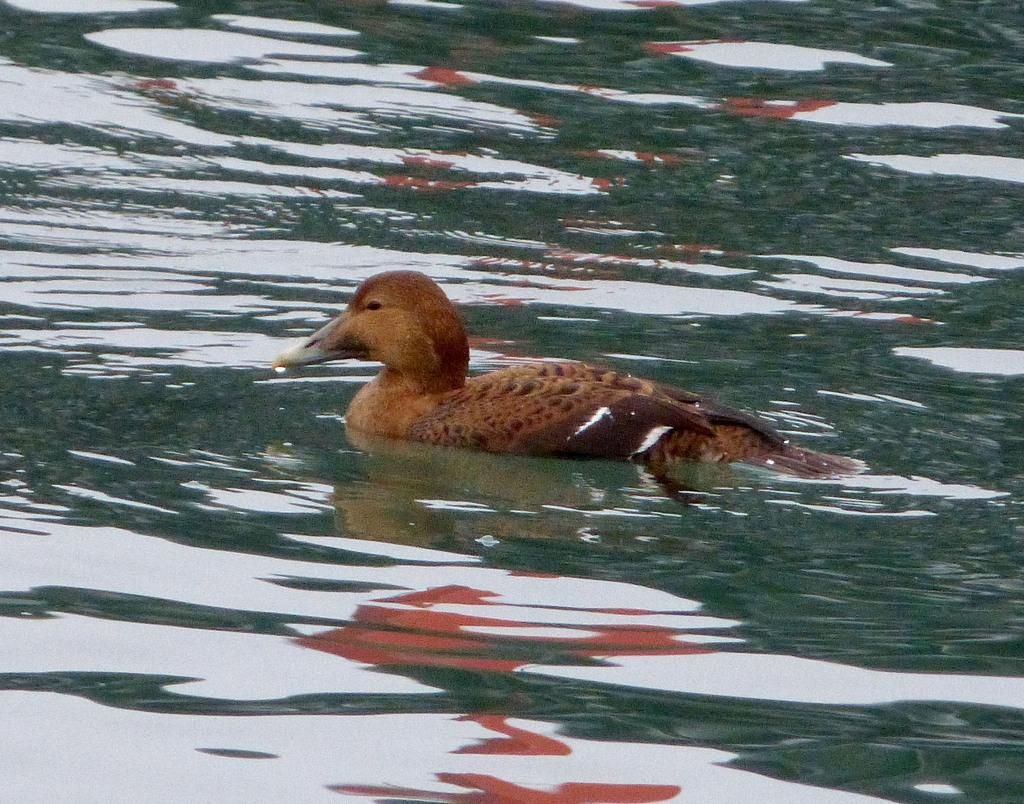What is the main subject in the center of the image? There is a bird in the center of the image. Where is the bird located? The bird is in the water. What color is the bird? The bird is brown in color. What can be seen in the background of the image? There is water visible in the background of the image. Where is the bucket located in the image? There is no bucket present in the image. What type of balloon can be seen floating in the water? There is no balloon present in the image; it features a bird in the water. 